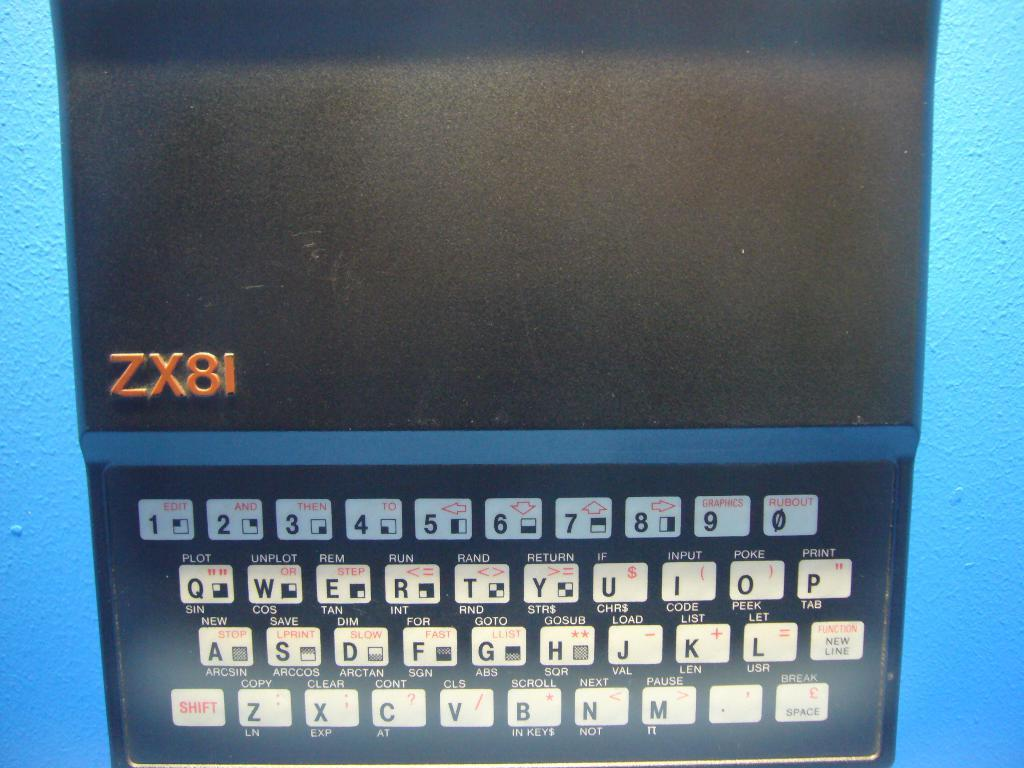<image>
Give a short and clear explanation of the subsequent image. some type of electronic with a blue rim and the letters ZX8I is on a blue table 